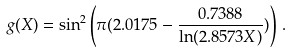Convert formula to latex. <formula><loc_0><loc_0><loc_500><loc_500>g ( X ) = \sin ^ { 2 } \left ( \pi ( 2 . 0 1 7 5 - \frac { 0 . 7 3 8 8 } { \ln ( 2 . 8 5 7 3 X ) } ) \right ) \, .</formula> 